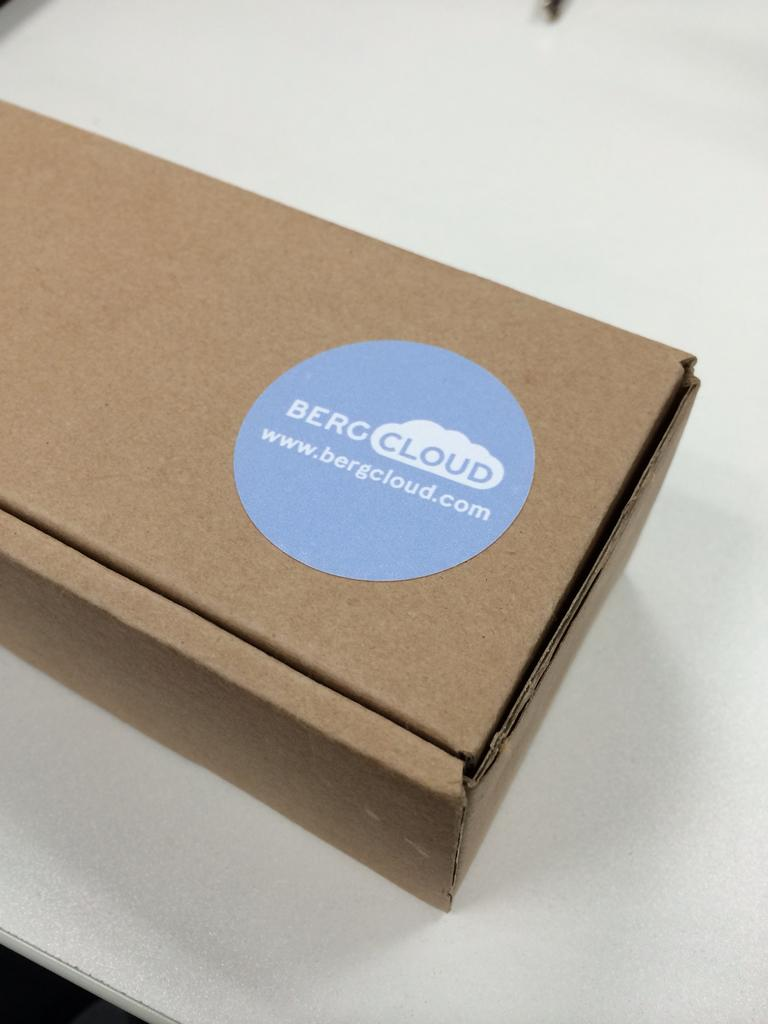<image>
Give a short and clear explanation of the subsequent image. A sticker reading Bergcloud is affixed to a cardboard box. 